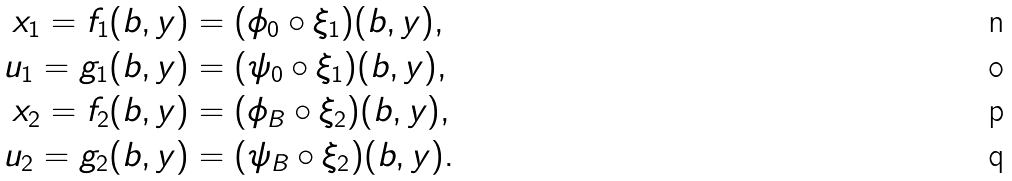<formula> <loc_0><loc_0><loc_500><loc_500>x _ { 1 } = f _ { 1 } ( b , y ) & = ( \phi _ { 0 } \circ \xi _ { 1 } ) ( b , y ) , \\ u _ { 1 } = g _ { 1 } ( b , y ) & = ( \psi _ { 0 } \circ \xi _ { 1 } ) ( b , y ) , \\ x _ { 2 } = f _ { 2 } ( b , y ) & = ( \phi _ { B } \circ \xi _ { 2 } ) ( b , y ) , \\ u _ { 2 } = g _ { 2 } ( b , y ) & = ( \psi _ { B } \circ \xi _ { 2 } ) ( b , y ) .</formula> 